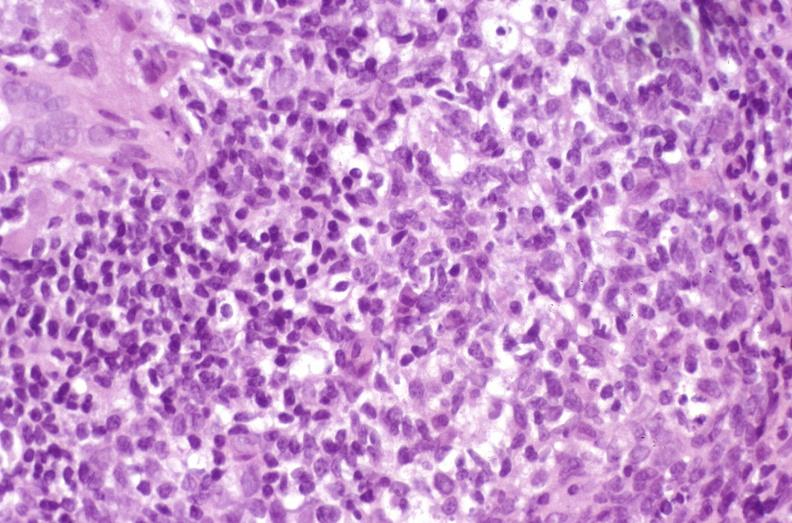s carcinoma superficial spreading present?
Answer the question using a single word or phrase. No 